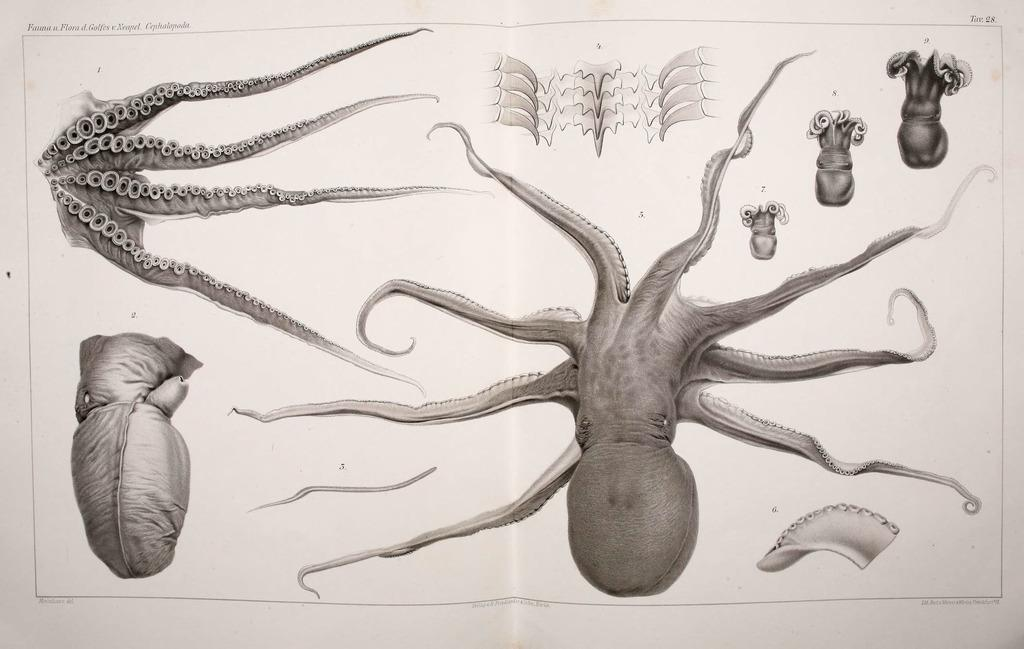What is the main subject of the image? The image is a picture of a poster. What is the focus of the poster? The poster contains information about water animals. How are the water animals represented on the poster? The poster includes illustrations or depictions of water animals and their parts. Can you tell me how many donkeys are depicted on the poster? There are no donkeys depicted on the poster; it focuses on water animals. What type of battle is taking place between the water animals on the poster? There is no battle depicted on the poster; it contains information and illustrations of water animals and their parts. 